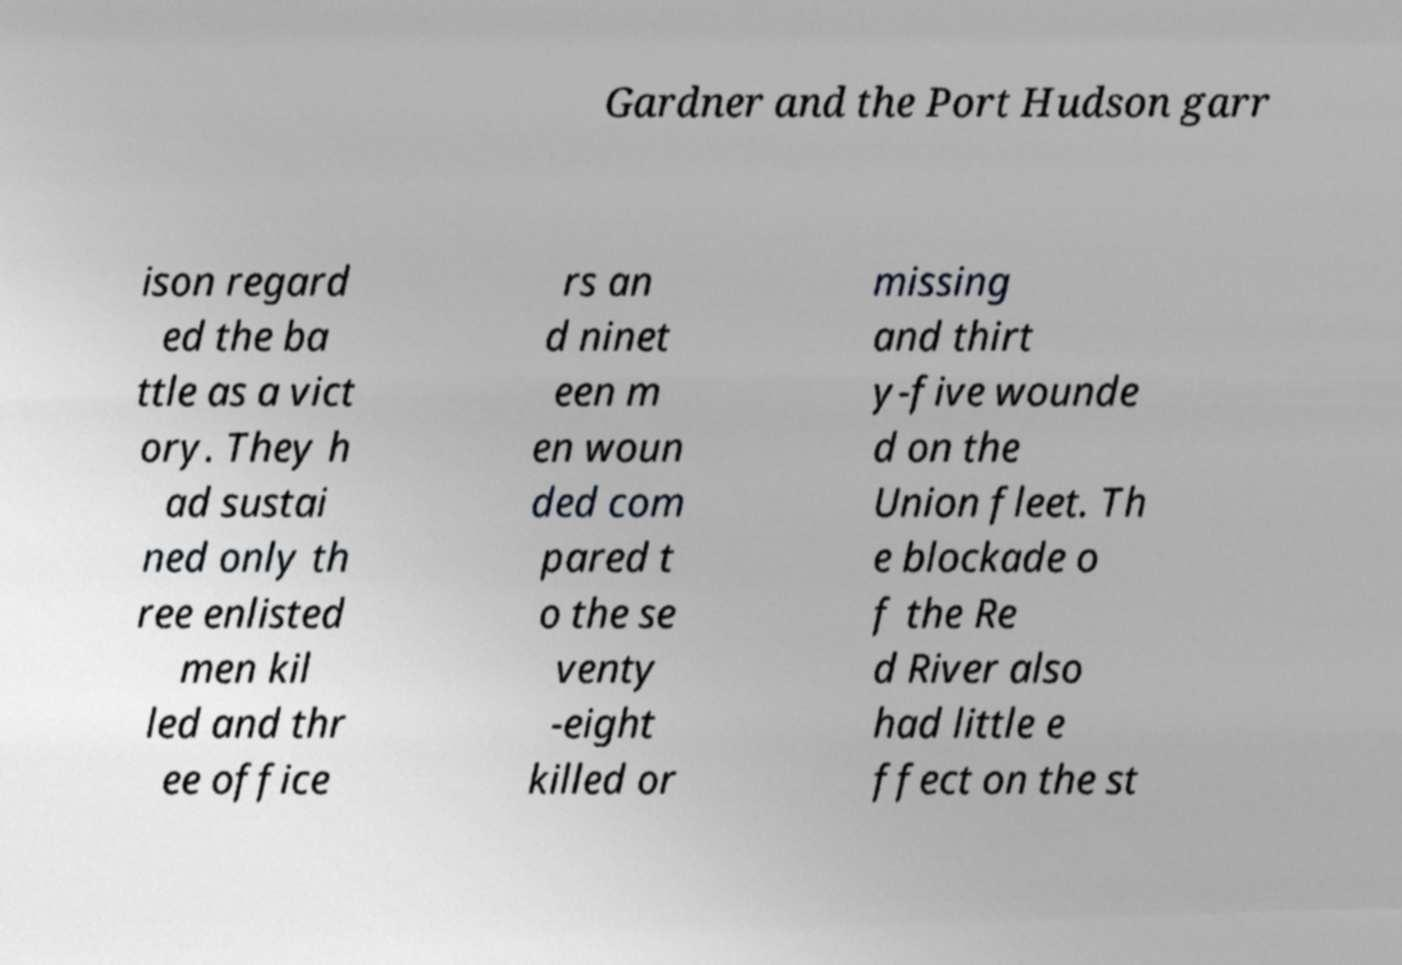What messages or text are displayed in this image? I need them in a readable, typed format. Gardner and the Port Hudson garr ison regard ed the ba ttle as a vict ory. They h ad sustai ned only th ree enlisted men kil led and thr ee office rs an d ninet een m en woun ded com pared t o the se venty -eight killed or missing and thirt y-five wounde d on the Union fleet. Th e blockade o f the Re d River also had little e ffect on the st 